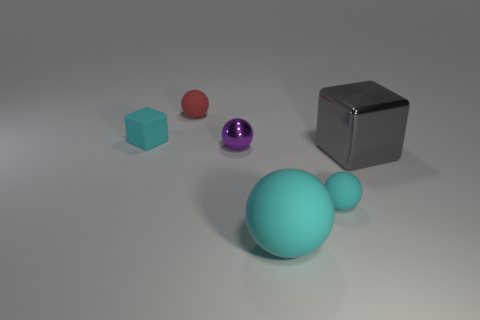What materials do the objects appear to be made from? The objects in the image seem to consist of different materials. The large cyan and small red objects have a matte, rubber-like texture indicative of rubber material. The medium purple object and the small cyan object have a reflective surface hinting at a metallic or plastic material. Moreover, the large cube has a reflective and smooth surface typical for a polished metal or chrome finish. 